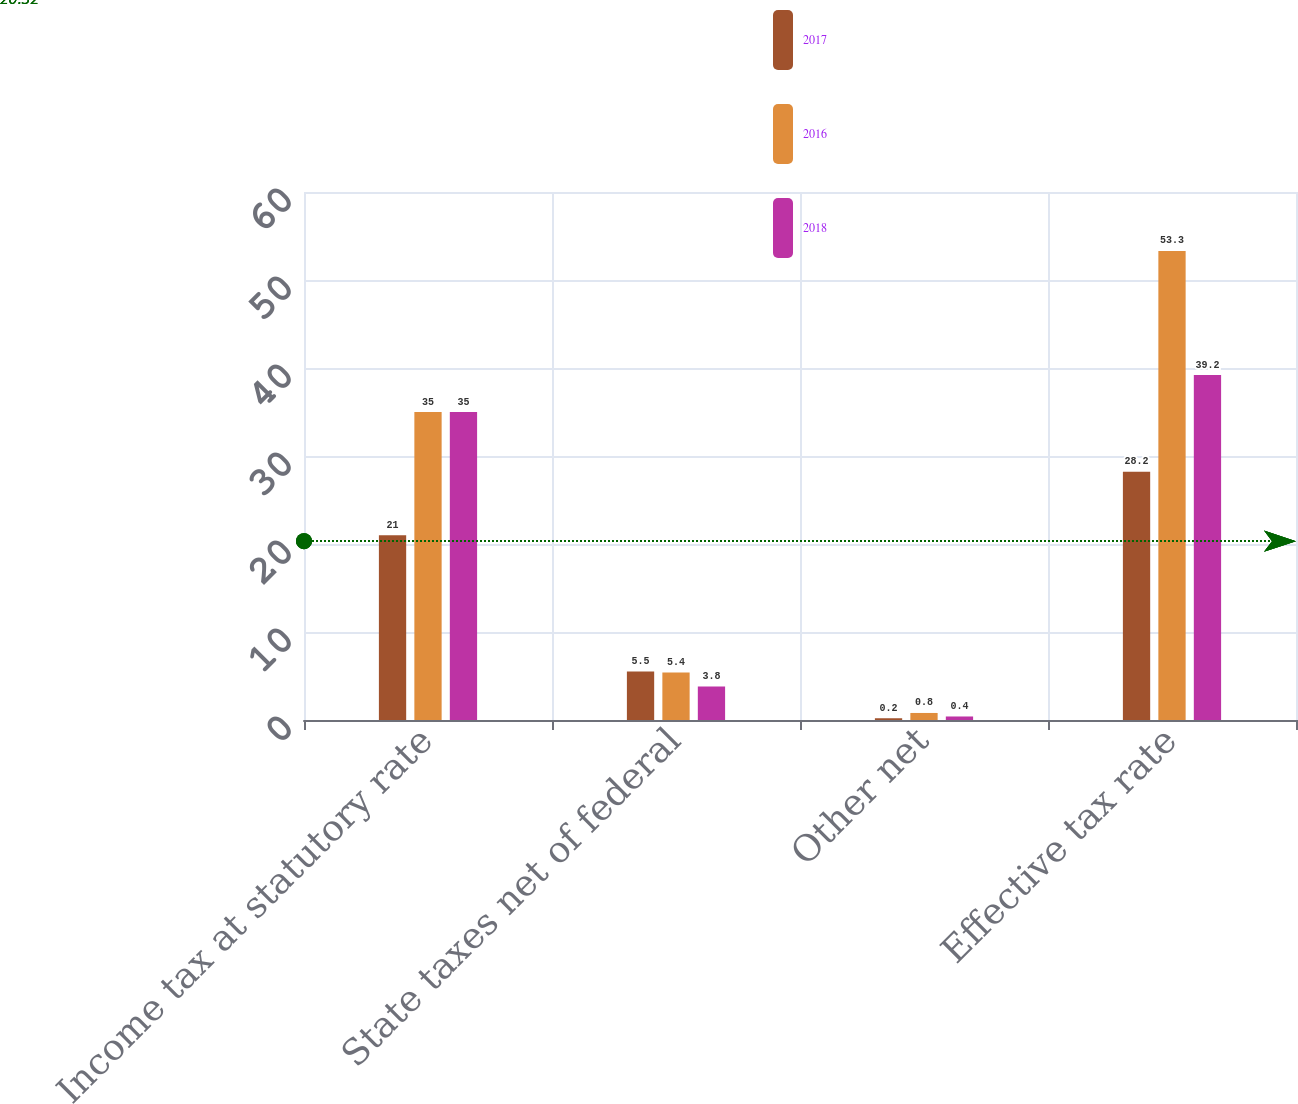Convert chart to OTSL. <chart><loc_0><loc_0><loc_500><loc_500><stacked_bar_chart><ecel><fcel>Income tax at statutory rate<fcel>State taxes net of federal<fcel>Other net<fcel>Effective tax rate<nl><fcel>2017<fcel>21<fcel>5.5<fcel>0.2<fcel>28.2<nl><fcel>2016<fcel>35<fcel>5.4<fcel>0.8<fcel>53.3<nl><fcel>2018<fcel>35<fcel>3.8<fcel>0.4<fcel>39.2<nl></chart> 